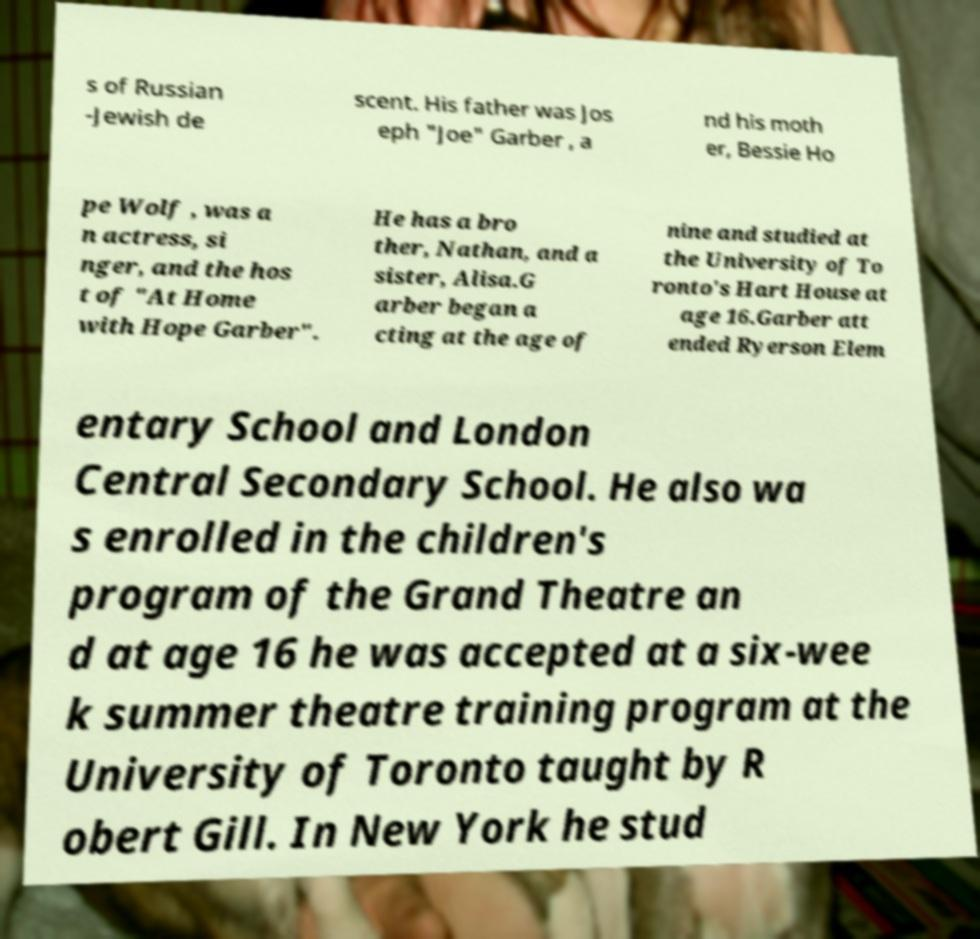Please identify and transcribe the text found in this image. s of Russian -Jewish de scent. His father was Jos eph "Joe" Garber , a nd his moth er, Bessie Ho pe Wolf , was a n actress, si nger, and the hos t of "At Home with Hope Garber". He has a bro ther, Nathan, and a sister, Alisa.G arber began a cting at the age of nine and studied at the University of To ronto's Hart House at age 16.Garber att ended Ryerson Elem entary School and London Central Secondary School. He also wa s enrolled in the children's program of the Grand Theatre an d at age 16 he was accepted at a six-wee k summer theatre training program at the University of Toronto taught by R obert Gill. In New York he stud 